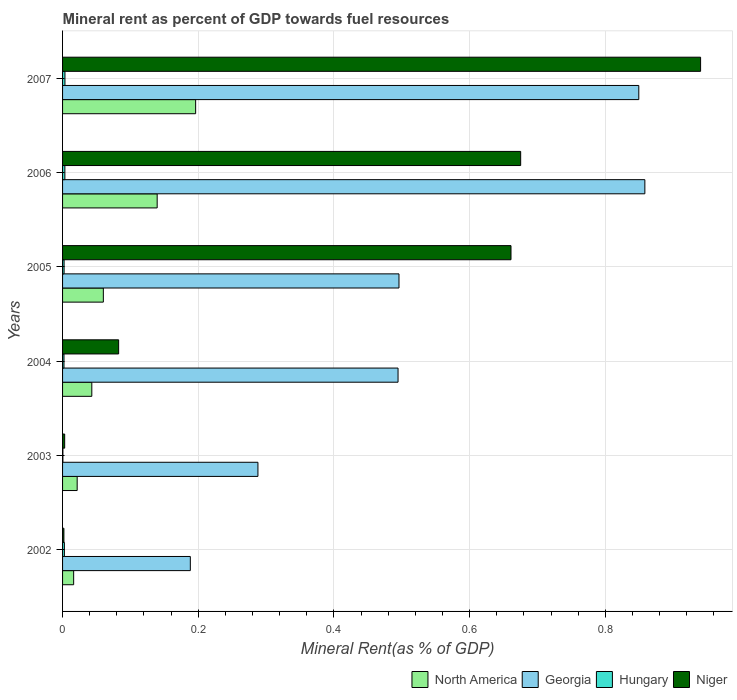How many groups of bars are there?
Your answer should be very brief. 6. Are the number of bars on each tick of the Y-axis equal?
Offer a very short reply. Yes. How many bars are there on the 5th tick from the top?
Give a very brief answer. 4. How many bars are there on the 5th tick from the bottom?
Keep it short and to the point. 4. What is the mineral rent in Georgia in 2003?
Provide a short and direct response. 0.29. Across all years, what is the maximum mineral rent in North America?
Make the answer very short. 0.2. Across all years, what is the minimum mineral rent in North America?
Offer a very short reply. 0.02. In which year was the mineral rent in Hungary maximum?
Make the answer very short. 2007. In which year was the mineral rent in Hungary minimum?
Ensure brevity in your answer.  2003. What is the total mineral rent in Hungary in the graph?
Your response must be concise. 0.01. What is the difference between the mineral rent in Georgia in 2004 and that in 2006?
Provide a short and direct response. -0.36. What is the difference between the mineral rent in North America in 2007 and the mineral rent in Niger in 2003?
Offer a very short reply. 0.19. What is the average mineral rent in Niger per year?
Make the answer very short. 0.39. In the year 2005, what is the difference between the mineral rent in Hungary and mineral rent in North America?
Ensure brevity in your answer.  -0.06. What is the ratio of the mineral rent in North America in 2003 to that in 2004?
Provide a succinct answer. 0.5. What is the difference between the highest and the second highest mineral rent in Hungary?
Ensure brevity in your answer.  0. What is the difference between the highest and the lowest mineral rent in North America?
Your answer should be very brief. 0.18. Is the sum of the mineral rent in North America in 2003 and 2006 greater than the maximum mineral rent in Niger across all years?
Give a very brief answer. No. Is it the case that in every year, the sum of the mineral rent in Hungary and mineral rent in Georgia is greater than the sum of mineral rent in Niger and mineral rent in North America?
Give a very brief answer. Yes. What does the 2nd bar from the top in 2005 represents?
Provide a succinct answer. Hungary. What does the 2nd bar from the bottom in 2002 represents?
Provide a succinct answer. Georgia. How many years are there in the graph?
Your answer should be compact. 6. Are the values on the major ticks of X-axis written in scientific E-notation?
Your answer should be very brief. No. Does the graph contain any zero values?
Provide a short and direct response. No. Does the graph contain grids?
Keep it short and to the point. Yes. Where does the legend appear in the graph?
Your answer should be very brief. Bottom right. How many legend labels are there?
Your response must be concise. 4. How are the legend labels stacked?
Your answer should be very brief. Horizontal. What is the title of the graph?
Your response must be concise. Mineral rent as percent of GDP towards fuel resources. What is the label or title of the X-axis?
Make the answer very short. Mineral Rent(as % of GDP). What is the label or title of the Y-axis?
Your response must be concise. Years. What is the Mineral Rent(as % of GDP) in North America in 2002?
Provide a succinct answer. 0.02. What is the Mineral Rent(as % of GDP) in Georgia in 2002?
Provide a succinct answer. 0.19. What is the Mineral Rent(as % of GDP) of Hungary in 2002?
Make the answer very short. 0. What is the Mineral Rent(as % of GDP) in Niger in 2002?
Your answer should be compact. 0. What is the Mineral Rent(as % of GDP) in North America in 2003?
Provide a short and direct response. 0.02. What is the Mineral Rent(as % of GDP) of Georgia in 2003?
Your answer should be very brief. 0.29. What is the Mineral Rent(as % of GDP) in Hungary in 2003?
Provide a succinct answer. 0. What is the Mineral Rent(as % of GDP) of Niger in 2003?
Ensure brevity in your answer.  0. What is the Mineral Rent(as % of GDP) in North America in 2004?
Make the answer very short. 0.04. What is the Mineral Rent(as % of GDP) in Georgia in 2004?
Provide a succinct answer. 0.49. What is the Mineral Rent(as % of GDP) of Hungary in 2004?
Give a very brief answer. 0. What is the Mineral Rent(as % of GDP) in Niger in 2004?
Provide a succinct answer. 0.08. What is the Mineral Rent(as % of GDP) in North America in 2005?
Your answer should be very brief. 0.06. What is the Mineral Rent(as % of GDP) of Georgia in 2005?
Make the answer very short. 0.5. What is the Mineral Rent(as % of GDP) in Hungary in 2005?
Make the answer very short. 0. What is the Mineral Rent(as % of GDP) in Niger in 2005?
Keep it short and to the point. 0.66. What is the Mineral Rent(as % of GDP) in North America in 2006?
Keep it short and to the point. 0.14. What is the Mineral Rent(as % of GDP) in Georgia in 2006?
Offer a terse response. 0.86. What is the Mineral Rent(as % of GDP) in Hungary in 2006?
Your response must be concise. 0. What is the Mineral Rent(as % of GDP) of Niger in 2006?
Offer a very short reply. 0.68. What is the Mineral Rent(as % of GDP) in North America in 2007?
Give a very brief answer. 0.2. What is the Mineral Rent(as % of GDP) in Georgia in 2007?
Give a very brief answer. 0.85. What is the Mineral Rent(as % of GDP) in Hungary in 2007?
Make the answer very short. 0. What is the Mineral Rent(as % of GDP) in Niger in 2007?
Your answer should be very brief. 0.94. Across all years, what is the maximum Mineral Rent(as % of GDP) of North America?
Your answer should be very brief. 0.2. Across all years, what is the maximum Mineral Rent(as % of GDP) in Georgia?
Offer a very short reply. 0.86. Across all years, what is the maximum Mineral Rent(as % of GDP) of Hungary?
Keep it short and to the point. 0. Across all years, what is the maximum Mineral Rent(as % of GDP) of Niger?
Offer a terse response. 0.94. Across all years, what is the minimum Mineral Rent(as % of GDP) in North America?
Provide a succinct answer. 0.02. Across all years, what is the minimum Mineral Rent(as % of GDP) of Georgia?
Keep it short and to the point. 0.19. Across all years, what is the minimum Mineral Rent(as % of GDP) in Hungary?
Your answer should be very brief. 0. Across all years, what is the minimum Mineral Rent(as % of GDP) of Niger?
Ensure brevity in your answer.  0. What is the total Mineral Rent(as % of GDP) of North America in the graph?
Ensure brevity in your answer.  0.48. What is the total Mineral Rent(as % of GDP) of Georgia in the graph?
Your answer should be compact. 3.17. What is the total Mineral Rent(as % of GDP) in Hungary in the graph?
Give a very brief answer. 0.01. What is the total Mineral Rent(as % of GDP) of Niger in the graph?
Offer a very short reply. 2.36. What is the difference between the Mineral Rent(as % of GDP) in North America in 2002 and that in 2003?
Give a very brief answer. -0.01. What is the difference between the Mineral Rent(as % of GDP) of Georgia in 2002 and that in 2003?
Keep it short and to the point. -0.1. What is the difference between the Mineral Rent(as % of GDP) of Hungary in 2002 and that in 2003?
Offer a very short reply. 0. What is the difference between the Mineral Rent(as % of GDP) of Niger in 2002 and that in 2003?
Make the answer very short. -0. What is the difference between the Mineral Rent(as % of GDP) in North America in 2002 and that in 2004?
Provide a short and direct response. -0.03. What is the difference between the Mineral Rent(as % of GDP) in Georgia in 2002 and that in 2004?
Your answer should be compact. -0.31. What is the difference between the Mineral Rent(as % of GDP) in Hungary in 2002 and that in 2004?
Offer a terse response. 0. What is the difference between the Mineral Rent(as % of GDP) in Niger in 2002 and that in 2004?
Give a very brief answer. -0.08. What is the difference between the Mineral Rent(as % of GDP) of North America in 2002 and that in 2005?
Offer a terse response. -0.04. What is the difference between the Mineral Rent(as % of GDP) in Georgia in 2002 and that in 2005?
Offer a very short reply. -0.31. What is the difference between the Mineral Rent(as % of GDP) in Hungary in 2002 and that in 2005?
Offer a terse response. 0. What is the difference between the Mineral Rent(as % of GDP) in Niger in 2002 and that in 2005?
Your response must be concise. -0.66. What is the difference between the Mineral Rent(as % of GDP) of North America in 2002 and that in 2006?
Keep it short and to the point. -0.12. What is the difference between the Mineral Rent(as % of GDP) in Georgia in 2002 and that in 2006?
Provide a succinct answer. -0.67. What is the difference between the Mineral Rent(as % of GDP) in Hungary in 2002 and that in 2006?
Give a very brief answer. -0. What is the difference between the Mineral Rent(as % of GDP) of Niger in 2002 and that in 2006?
Offer a terse response. -0.67. What is the difference between the Mineral Rent(as % of GDP) of North America in 2002 and that in 2007?
Give a very brief answer. -0.18. What is the difference between the Mineral Rent(as % of GDP) of Georgia in 2002 and that in 2007?
Ensure brevity in your answer.  -0.66. What is the difference between the Mineral Rent(as % of GDP) in Hungary in 2002 and that in 2007?
Your answer should be very brief. -0. What is the difference between the Mineral Rent(as % of GDP) of Niger in 2002 and that in 2007?
Offer a terse response. -0.94. What is the difference between the Mineral Rent(as % of GDP) of North America in 2003 and that in 2004?
Your answer should be very brief. -0.02. What is the difference between the Mineral Rent(as % of GDP) in Georgia in 2003 and that in 2004?
Your response must be concise. -0.21. What is the difference between the Mineral Rent(as % of GDP) of Hungary in 2003 and that in 2004?
Offer a very short reply. -0. What is the difference between the Mineral Rent(as % of GDP) of Niger in 2003 and that in 2004?
Provide a succinct answer. -0.08. What is the difference between the Mineral Rent(as % of GDP) of North America in 2003 and that in 2005?
Provide a succinct answer. -0.04. What is the difference between the Mineral Rent(as % of GDP) in Georgia in 2003 and that in 2005?
Provide a succinct answer. -0.21. What is the difference between the Mineral Rent(as % of GDP) of Hungary in 2003 and that in 2005?
Your response must be concise. -0. What is the difference between the Mineral Rent(as % of GDP) of Niger in 2003 and that in 2005?
Your answer should be compact. -0.66. What is the difference between the Mineral Rent(as % of GDP) of North America in 2003 and that in 2006?
Your response must be concise. -0.12. What is the difference between the Mineral Rent(as % of GDP) in Georgia in 2003 and that in 2006?
Offer a terse response. -0.57. What is the difference between the Mineral Rent(as % of GDP) of Hungary in 2003 and that in 2006?
Your answer should be very brief. -0. What is the difference between the Mineral Rent(as % of GDP) of Niger in 2003 and that in 2006?
Keep it short and to the point. -0.67. What is the difference between the Mineral Rent(as % of GDP) of North America in 2003 and that in 2007?
Offer a very short reply. -0.17. What is the difference between the Mineral Rent(as % of GDP) in Georgia in 2003 and that in 2007?
Offer a very short reply. -0.56. What is the difference between the Mineral Rent(as % of GDP) of Hungary in 2003 and that in 2007?
Your response must be concise. -0. What is the difference between the Mineral Rent(as % of GDP) in Niger in 2003 and that in 2007?
Ensure brevity in your answer.  -0.94. What is the difference between the Mineral Rent(as % of GDP) in North America in 2004 and that in 2005?
Provide a succinct answer. -0.02. What is the difference between the Mineral Rent(as % of GDP) in Georgia in 2004 and that in 2005?
Keep it short and to the point. -0. What is the difference between the Mineral Rent(as % of GDP) of Hungary in 2004 and that in 2005?
Provide a succinct answer. -0. What is the difference between the Mineral Rent(as % of GDP) in Niger in 2004 and that in 2005?
Offer a very short reply. -0.58. What is the difference between the Mineral Rent(as % of GDP) in North America in 2004 and that in 2006?
Offer a terse response. -0.1. What is the difference between the Mineral Rent(as % of GDP) in Georgia in 2004 and that in 2006?
Offer a terse response. -0.36. What is the difference between the Mineral Rent(as % of GDP) in Hungary in 2004 and that in 2006?
Provide a short and direct response. -0. What is the difference between the Mineral Rent(as % of GDP) in Niger in 2004 and that in 2006?
Provide a succinct answer. -0.59. What is the difference between the Mineral Rent(as % of GDP) of North America in 2004 and that in 2007?
Provide a short and direct response. -0.15. What is the difference between the Mineral Rent(as % of GDP) in Georgia in 2004 and that in 2007?
Provide a short and direct response. -0.35. What is the difference between the Mineral Rent(as % of GDP) in Hungary in 2004 and that in 2007?
Offer a terse response. -0. What is the difference between the Mineral Rent(as % of GDP) of Niger in 2004 and that in 2007?
Provide a short and direct response. -0.86. What is the difference between the Mineral Rent(as % of GDP) in North America in 2005 and that in 2006?
Make the answer very short. -0.08. What is the difference between the Mineral Rent(as % of GDP) in Georgia in 2005 and that in 2006?
Offer a terse response. -0.36. What is the difference between the Mineral Rent(as % of GDP) in Hungary in 2005 and that in 2006?
Your answer should be very brief. -0. What is the difference between the Mineral Rent(as % of GDP) of Niger in 2005 and that in 2006?
Offer a terse response. -0.01. What is the difference between the Mineral Rent(as % of GDP) of North America in 2005 and that in 2007?
Your answer should be very brief. -0.14. What is the difference between the Mineral Rent(as % of GDP) in Georgia in 2005 and that in 2007?
Your answer should be compact. -0.35. What is the difference between the Mineral Rent(as % of GDP) in Hungary in 2005 and that in 2007?
Provide a succinct answer. -0. What is the difference between the Mineral Rent(as % of GDP) of Niger in 2005 and that in 2007?
Make the answer very short. -0.28. What is the difference between the Mineral Rent(as % of GDP) in North America in 2006 and that in 2007?
Ensure brevity in your answer.  -0.06. What is the difference between the Mineral Rent(as % of GDP) in Georgia in 2006 and that in 2007?
Ensure brevity in your answer.  0.01. What is the difference between the Mineral Rent(as % of GDP) of Hungary in 2006 and that in 2007?
Provide a short and direct response. -0. What is the difference between the Mineral Rent(as % of GDP) of Niger in 2006 and that in 2007?
Your response must be concise. -0.27. What is the difference between the Mineral Rent(as % of GDP) of North America in 2002 and the Mineral Rent(as % of GDP) of Georgia in 2003?
Your response must be concise. -0.27. What is the difference between the Mineral Rent(as % of GDP) in North America in 2002 and the Mineral Rent(as % of GDP) in Hungary in 2003?
Your response must be concise. 0.02. What is the difference between the Mineral Rent(as % of GDP) of North America in 2002 and the Mineral Rent(as % of GDP) of Niger in 2003?
Your response must be concise. 0.01. What is the difference between the Mineral Rent(as % of GDP) in Georgia in 2002 and the Mineral Rent(as % of GDP) in Hungary in 2003?
Your answer should be compact. 0.19. What is the difference between the Mineral Rent(as % of GDP) of Georgia in 2002 and the Mineral Rent(as % of GDP) of Niger in 2003?
Keep it short and to the point. 0.19. What is the difference between the Mineral Rent(as % of GDP) of Hungary in 2002 and the Mineral Rent(as % of GDP) of Niger in 2003?
Offer a very short reply. -0. What is the difference between the Mineral Rent(as % of GDP) in North America in 2002 and the Mineral Rent(as % of GDP) in Georgia in 2004?
Your response must be concise. -0.48. What is the difference between the Mineral Rent(as % of GDP) in North America in 2002 and the Mineral Rent(as % of GDP) in Hungary in 2004?
Give a very brief answer. 0.01. What is the difference between the Mineral Rent(as % of GDP) in North America in 2002 and the Mineral Rent(as % of GDP) in Niger in 2004?
Your response must be concise. -0.07. What is the difference between the Mineral Rent(as % of GDP) in Georgia in 2002 and the Mineral Rent(as % of GDP) in Hungary in 2004?
Your answer should be very brief. 0.19. What is the difference between the Mineral Rent(as % of GDP) in Georgia in 2002 and the Mineral Rent(as % of GDP) in Niger in 2004?
Your answer should be compact. 0.11. What is the difference between the Mineral Rent(as % of GDP) of Hungary in 2002 and the Mineral Rent(as % of GDP) of Niger in 2004?
Keep it short and to the point. -0.08. What is the difference between the Mineral Rent(as % of GDP) of North America in 2002 and the Mineral Rent(as % of GDP) of Georgia in 2005?
Provide a short and direct response. -0.48. What is the difference between the Mineral Rent(as % of GDP) in North America in 2002 and the Mineral Rent(as % of GDP) in Hungary in 2005?
Ensure brevity in your answer.  0.01. What is the difference between the Mineral Rent(as % of GDP) of North America in 2002 and the Mineral Rent(as % of GDP) of Niger in 2005?
Provide a succinct answer. -0.64. What is the difference between the Mineral Rent(as % of GDP) in Georgia in 2002 and the Mineral Rent(as % of GDP) in Hungary in 2005?
Your response must be concise. 0.19. What is the difference between the Mineral Rent(as % of GDP) of Georgia in 2002 and the Mineral Rent(as % of GDP) of Niger in 2005?
Give a very brief answer. -0.47. What is the difference between the Mineral Rent(as % of GDP) of Hungary in 2002 and the Mineral Rent(as % of GDP) of Niger in 2005?
Offer a very short reply. -0.66. What is the difference between the Mineral Rent(as % of GDP) of North America in 2002 and the Mineral Rent(as % of GDP) of Georgia in 2006?
Offer a very short reply. -0.84. What is the difference between the Mineral Rent(as % of GDP) of North America in 2002 and the Mineral Rent(as % of GDP) of Hungary in 2006?
Your response must be concise. 0.01. What is the difference between the Mineral Rent(as % of GDP) of North America in 2002 and the Mineral Rent(as % of GDP) of Niger in 2006?
Ensure brevity in your answer.  -0.66. What is the difference between the Mineral Rent(as % of GDP) of Georgia in 2002 and the Mineral Rent(as % of GDP) of Hungary in 2006?
Make the answer very short. 0.18. What is the difference between the Mineral Rent(as % of GDP) of Georgia in 2002 and the Mineral Rent(as % of GDP) of Niger in 2006?
Give a very brief answer. -0.49. What is the difference between the Mineral Rent(as % of GDP) in Hungary in 2002 and the Mineral Rent(as % of GDP) in Niger in 2006?
Provide a succinct answer. -0.67. What is the difference between the Mineral Rent(as % of GDP) of North America in 2002 and the Mineral Rent(as % of GDP) of Georgia in 2007?
Provide a succinct answer. -0.83. What is the difference between the Mineral Rent(as % of GDP) in North America in 2002 and the Mineral Rent(as % of GDP) in Hungary in 2007?
Give a very brief answer. 0.01. What is the difference between the Mineral Rent(as % of GDP) of North America in 2002 and the Mineral Rent(as % of GDP) of Niger in 2007?
Make the answer very short. -0.92. What is the difference between the Mineral Rent(as % of GDP) of Georgia in 2002 and the Mineral Rent(as % of GDP) of Hungary in 2007?
Offer a terse response. 0.18. What is the difference between the Mineral Rent(as % of GDP) in Georgia in 2002 and the Mineral Rent(as % of GDP) in Niger in 2007?
Ensure brevity in your answer.  -0.75. What is the difference between the Mineral Rent(as % of GDP) of Hungary in 2002 and the Mineral Rent(as % of GDP) of Niger in 2007?
Offer a very short reply. -0.94. What is the difference between the Mineral Rent(as % of GDP) in North America in 2003 and the Mineral Rent(as % of GDP) in Georgia in 2004?
Ensure brevity in your answer.  -0.47. What is the difference between the Mineral Rent(as % of GDP) in North America in 2003 and the Mineral Rent(as % of GDP) in Hungary in 2004?
Make the answer very short. 0.02. What is the difference between the Mineral Rent(as % of GDP) of North America in 2003 and the Mineral Rent(as % of GDP) of Niger in 2004?
Provide a short and direct response. -0.06. What is the difference between the Mineral Rent(as % of GDP) in Georgia in 2003 and the Mineral Rent(as % of GDP) in Hungary in 2004?
Offer a terse response. 0.29. What is the difference between the Mineral Rent(as % of GDP) in Georgia in 2003 and the Mineral Rent(as % of GDP) in Niger in 2004?
Your answer should be compact. 0.21. What is the difference between the Mineral Rent(as % of GDP) of Hungary in 2003 and the Mineral Rent(as % of GDP) of Niger in 2004?
Offer a very short reply. -0.08. What is the difference between the Mineral Rent(as % of GDP) in North America in 2003 and the Mineral Rent(as % of GDP) in Georgia in 2005?
Keep it short and to the point. -0.47. What is the difference between the Mineral Rent(as % of GDP) in North America in 2003 and the Mineral Rent(as % of GDP) in Hungary in 2005?
Provide a short and direct response. 0.02. What is the difference between the Mineral Rent(as % of GDP) of North America in 2003 and the Mineral Rent(as % of GDP) of Niger in 2005?
Your response must be concise. -0.64. What is the difference between the Mineral Rent(as % of GDP) in Georgia in 2003 and the Mineral Rent(as % of GDP) in Hungary in 2005?
Provide a short and direct response. 0.29. What is the difference between the Mineral Rent(as % of GDP) in Georgia in 2003 and the Mineral Rent(as % of GDP) in Niger in 2005?
Your answer should be very brief. -0.37. What is the difference between the Mineral Rent(as % of GDP) of Hungary in 2003 and the Mineral Rent(as % of GDP) of Niger in 2005?
Make the answer very short. -0.66. What is the difference between the Mineral Rent(as % of GDP) in North America in 2003 and the Mineral Rent(as % of GDP) in Georgia in 2006?
Your answer should be compact. -0.84. What is the difference between the Mineral Rent(as % of GDP) of North America in 2003 and the Mineral Rent(as % of GDP) of Hungary in 2006?
Your answer should be very brief. 0.02. What is the difference between the Mineral Rent(as % of GDP) of North America in 2003 and the Mineral Rent(as % of GDP) of Niger in 2006?
Provide a short and direct response. -0.65. What is the difference between the Mineral Rent(as % of GDP) in Georgia in 2003 and the Mineral Rent(as % of GDP) in Hungary in 2006?
Give a very brief answer. 0.28. What is the difference between the Mineral Rent(as % of GDP) of Georgia in 2003 and the Mineral Rent(as % of GDP) of Niger in 2006?
Keep it short and to the point. -0.39. What is the difference between the Mineral Rent(as % of GDP) of Hungary in 2003 and the Mineral Rent(as % of GDP) of Niger in 2006?
Your answer should be very brief. -0.67. What is the difference between the Mineral Rent(as % of GDP) in North America in 2003 and the Mineral Rent(as % of GDP) in Georgia in 2007?
Your answer should be very brief. -0.83. What is the difference between the Mineral Rent(as % of GDP) in North America in 2003 and the Mineral Rent(as % of GDP) in Hungary in 2007?
Give a very brief answer. 0.02. What is the difference between the Mineral Rent(as % of GDP) of North America in 2003 and the Mineral Rent(as % of GDP) of Niger in 2007?
Ensure brevity in your answer.  -0.92. What is the difference between the Mineral Rent(as % of GDP) in Georgia in 2003 and the Mineral Rent(as % of GDP) in Hungary in 2007?
Ensure brevity in your answer.  0.28. What is the difference between the Mineral Rent(as % of GDP) of Georgia in 2003 and the Mineral Rent(as % of GDP) of Niger in 2007?
Your answer should be compact. -0.65. What is the difference between the Mineral Rent(as % of GDP) in Hungary in 2003 and the Mineral Rent(as % of GDP) in Niger in 2007?
Make the answer very short. -0.94. What is the difference between the Mineral Rent(as % of GDP) in North America in 2004 and the Mineral Rent(as % of GDP) in Georgia in 2005?
Your answer should be very brief. -0.45. What is the difference between the Mineral Rent(as % of GDP) in North America in 2004 and the Mineral Rent(as % of GDP) in Hungary in 2005?
Your answer should be very brief. 0.04. What is the difference between the Mineral Rent(as % of GDP) in North America in 2004 and the Mineral Rent(as % of GDP) in Niger in 2005?
Offer a terse response. -0.62. What is the difference between the Mineral Rent(as % of GDP) in Georgia in 2004 and the Mineral Rent(as % of GDP) in Hungary in 2005?
Offer a very short reply. 0.49. What is the difference between the Mineral Rent(as % of GDP) in Georgia in 2004 and the Mineral Rent(as % of GDP) in Niger in 2005?
Make the answer very short. -0.17. What is the difference between the Mineral Rent(as % of GDP) in Hungary in 2004 and the Mineral Rent(as % of GDP) in Niger in 2005?
Keep it short and to the point. -0.66. What is the difference between the Mineral Rent(as % of GDP) in North America in 2004 and the Mineral Rent(as % of GDP) in Georgia in 2006?
Your response must be concise. -0.82. What is the difference between the Mineral Rent(as % of GDP) of North America in 2004 and the Mineral Rent(as % of GDP) of Hungary in 2006?
Keep it short and to the point. 0.04. What is the difference between the Mineral Rent(as % of GDP) of North America in 2004 and the Mineral Rent(as % of GDP) of Niger in 2006?
Provide a short and direct response. -0.63. What is the difference between the Mineral Rent(as % of GDP) in Georgia in 2004 and the Mineral Rent(as % of GDP) in Hungary in 2006?
Make the answer very short. 0.49. What is the difference between the Mineral Rent(as % of GDP) of Georgia in 2004 and the Mineral Rent(as % of GDP) of Niger in 2006?
Make the answer very short. -0.18. What is the difference between the Mineral Rent(as % of GDP) in Hungary in 2004 and the Mineral Rent(as % of GDP) in Niger in 2006?
Make the answer very short. -0.67. What is the difference between the Mineral Rent(as % of GDP) in North America in 2004 and the Mineral Rent(as % of GDP) in Georgia in 2007?
Your response must be concise. -0.81. What is the difference between the Mineral Rent(as % of GDP) in North America in 2004 and the Mineral Rent(as % of GDP) in Hungary in 2007?
Offer a terse response. 0.04. What is the difference between the Mineral Rent(as % of GDP) of North America in 2004 and the Mineral Rent(as % of GDP) of Niger in 2007?
Make the answer very short. -0.9. What is the difference between the Mineral Rent(as % of GDP) in Georgia in 2004 and the Mineral Rent(as % of GDP) in Hungary in 2007?
Give a very brief answer. 0.49. What is the difference between the Mineral Rent(as % of GDP) of Georgia in 2004 and the Mineral Rent(as % of GDP) of Niger in 2007?
Your answer should be very brief. -0.45. What is the difference between the Mineral Rent(as % of GDP) in Hungary in 2004 and the Mineral Rent(as % of GDP) in Niger in 2007?
Your response must be concise. -0.94. What is the difference between the Mineral Rent(as % of GDP) in North America in 2005 and the Mineral Rent(as % of GDP) in Georgia in 2006?
Offer a very short reply. -0.8. What is the difference between the Mineral Rent(as % of GDP) in North America in 2005 and the Mineral Rent(as % of GDP) in Hungary in 2006?
Provide a short and direct response. 0.06. What is the difference between the Mineral Rent(as % of GDP) of North America in 2005 and the Mineral Rent(as % of GDP) of Niger in 2006?
Your response must be concise. -0.62. What is the difference between the Mineral Rent(as % of GDP) in Georgia in 2005 and the Mineral Rent(as % of GDP) in Hungary in 2006?
Give a very brief answer. 0.49. What is the difference between the Mineral Rent(as % of GDP) of Georgia in 2005 and the Mineral Rent(as % of GDP) of Niger in 2006?
Your response must be concise. -0.18. What is the difference between the Mineral Rent(as % of GDP) of Hungary in 2005 and the Mineral Rent(as % of GDP) of Niger in 2006?
Your answer should be very brief. -0.67. What is the difference between the Mineral Rent(as % of GDP) in North America in 2005 and the Mineral Rent(as % of GDP) in Georgia in 2007?
Make the answer very short. -0.79. What is the difference between the Mineral Rent(as % of GDP) in North America in 2005 and the Mineral Rent(as % of GDP) in Hungary in 2007?
Offer a terse response. 0.06. What is the difference between the Mineral Rent(as % of GDP) in North America in 2005 and the Mineral Rent(as % of GDP) in Niger in 2007?
Ensure brevity in your answer.  -0.88. What is the difference between the Mineral Rent(as % of GDP) of Georgia in 2005 and the Mineral Rent(as % of GDP) of Hungary in 2007?
Make the answer very short. 0.49. What is the difference between the Mineral Rent(as % of GDP) in Georgia in 2005 and the Mineral Rent(as % of GDP) in Niger in 2007?
Ensure brevity in your answer.  -0.44. What is the difference between the Mineral Rent(as % of GDP) in Hungary in 2005 and the Mineral Rent(as % of GDP) in Niger in 2007?
Make the answer very short. -0.94. What is the difference between the Mineral Rent(as % of GDP) in North America in 2006 and the Mineral Rent(as % of GDP) in Georgia in 2007?
Offer a terse response. -0.71. What is the difference between the Mineral Rent(as % of GDP) in North America in 2006 and the Mineral Rent(as % of GDP) in Hungary in 2007?
Your answer should be compact. 0.14. What is the difference between the Mineral Rent(as % of GDP) of North America in 2006 and the Mineral Rent(as % of GDP) of Niger in 2007?
Keep it short and to the point. -0.8. What is the difference between the Mineral Rent(as % of GDP) in Georgia in 2006 and the Mineral Rent(as % of GDP) in Hungary in 2007?
Give a very brief answer. 0.85. What is the difference between the Mineral Rent(as % of GDP) in Georgia in 2006 and the Mineral Rent(as % of GDP) in Niger in 2007?
Provide a short and direct response. -0.08. What is the difference between the Mineral Rent(as % of GDP) in Hungary in 2006 and the Mineral Rent(as % of GDP) in Niger in 2007?
Your response must be concise. -0.94. What is the average Mineral Rent(as % of GDP) of North America per year?
Make the answer very short. 0.08. What is the average Mineral Rent(as % of GDP) in Georgia per year?
Your answer should be compact. 0.53. What is the average Mineral Rent(as % of GDP) in Hungary per year?
Make the answer very short. 0. What is the average Mineral Rent(as % of GDP) in Niger per year?
Your response must be concise. 0.39. In the year 2002, what is the difference between the Mineral Rent(as % of GDP) of North America and Mineral Rent(as % of GDP) of Georgia?
Make the answer very short. -0.17. In the year 2002, what is the difference between the Mineral Rent(as % of GDP) in North America and Mineral Rent(as % of GDP) in Hungary?
Provide a short and direct response. 0.01. In the year 2002, what is the difference between the Mineral Rent(as % of GDP) in North America and Mineral Rent(as % of GDP) in Niger?
Provide a succinct answer. 0.01. In the year 2002, what is the difference between the Mineral Rent(as % of GDP) of Georgia and Mineral Rent(as % of GDP) of Hungary?
Provide a succinct answer. 0.19. In the year 2002, what is the difference between the Mineral Rent(as % of GDP) in Georgia and Mineral Rent(as % of GDP) in Niger?
Provide a short and direct response. 0.19. In the year 2002, what is the difference between the Mineral Rent(as % of GDP) in Hungary and Mineral Rent(as % of GDP) in Niger?
Make the answer very short. 0. In the year 2003, what is the difference between the Mineral Rent(as % of GDP) of North America and Mineral Rent(as % of GDP) of Georgia?
Offer a very short reply. -0.27. In the year 2003, what is the difference between the Mineral Rent(as % of GDP) in North America and Mineral Rent(as % of GDP) in Hungary?
Give a very brief answer. 0.02. In the year 2003, what is the difference between the Mineral Rent(as % of GDP) in North America and Mineral Rent(as % of GDP) in Niger?
Your answer should be very brief. 0.02. In the year 2003, what is the difference between the Mineral Rent(as % of GDP) in Georgia and Mineral Rent(as % of GDP) in Hungary?
Give a very brief answer. 0.29. In the year 2003, what is the difference between the Mineral Rent(as % of GDP) of Georgia and Mineral Rent(as % of GDP) of Niger?
Your answer should be very brief. 0.28. In the year 2003, what is the difference between the Mineral Rent(as % of GDP) of Hungary and Mineral Rent(as % of GDP) of Niger?
Your answer should be compact. -0. In the year 2004, what is the difference between the Mineral Rent(as % of GDP) of North America and Mineral Rent(as % of GDP) of Georgia?
Give a very brief answer. -0.45. In the year 2004, what is the difference between the Mineral Rent(as % of GDP) in North America and Mineral Rent(as % of GDP) in Hungary?
Ensure brevity in your answer.  0.04. In the year 2004, what is the difference between the Mineral Rent(as % of GDP) of North America and Mineral Rent(as % of GDP) of Niger?
Keep it short and to the point. -0.04. In the year 2004, what is the difference between the Mineral Rent(as % of GDP) in Georgia and Mineral Rent(as % of GDP) in Hungary?
Your answer should be very brief. 0.49. In the year 2004, what is the difference between the Mineral Rent(as % of GDP) of Georgia and Mineral Rent(as % of GDP) of Niger?
Ensure brevity in your answer.  0.41. In the year 2004, what is the difference between the Mineral Rent(as % of GDP) in Hungary and Mineral Rent(as % of GDP) in Niger?
Make the answer very short. -0.08. In the year 2005, what is the difference between the Mineral Rent(as % of GDP) in North America and Mineral Rent(as % of GDP) in Georgia?
Provide a short and direct response. -0.44. In the year 2005, what is the difference between the Mineral Rent(as % of GDP) of North America and Mineral Rent(as % of GDP) of Hungary?
Give a very brief answer. 0.06. In the year 2005, what is the difference between the Mineral Rent(as % of GDP) of North America and Mineral Rent(as % of GDP) of Niger?
Offer a very short reply. -0.6. In the year 2005, what is the difference between the Mineral Rent(as % of GDP) of Georgia and Mineral Rent(as % of GDP) of Hungary?
Keep it short and to the point. 0.49. In the year 2005, what is the difference between the Mineral Rent(as % of GDP) of Georgia and Mineral Rent(as % of GDP) of Niger?
Your answer should be very brief. -0.17. In the year 2005, what is the difference between the Mineral Rent(as % of GDP) of Hungary and Mineral Rent(as % of GDP) of Niger?
Offer a very short reply. -0.66. In the year 2006, what is the difference between the Mineral Rent(as % of GDP) in North America and Mineral Rent(as % of GDP) in Georgia?
Provide a short and direct response. -0.72. In the year 2006, what is the difference between the Mineral Rent(as % of GDP) of North America and Mineral Rent(as % of GDP) of Hungary?
Keep it short and to the point. 0.14. In the year 2006, what is the difference between the Mineral Rent(as % of GDP) of North America and Mineral Rent(as % of GDP) of Niger?
Offer a very short reply. -0.54. In the year 2006, what is the difference between the Mineral Rent(as % of GDP) of Georgia and Mineral Rent(as % of GDP) of Hungary?
Provide a succinct answer. 0.85. In the year 2006, what is the difference between the Mineral Rent(as % of GDP) of Georgia and Mineral Rent(as % of GDP) of Niger?
Ensure brevity in your answer.  0.18. In the year 2006, what is the difference between the Mineral Rent(as % of GDP) of Hungary and Mineral Rent(as % of GDP) of Niger?
Ensure brevity in your answer.  -0.67. In the year 2007, what is the difference between the Mineral Rent(as % of GDP) in North America and Mineral Rent(as % of GDP) in Georgia?
Offer a very short reply. -0.65. In the year 2007, what is the difference between the Mineral Rent(as % of GDP) in North America and Mineral Rent(as % of GDP) in Hungary?
Ensure brevity in your answer.  0.19. In the year 2007, what is the difference between the Mineral Rent(as % of GDP) of North America and Mineral Rent(as % of GDP) of Niger?
Give a very brief answer. -0.74. In the year 2007, what is the difference between the Mineral Rent(as % of GDP) of Georgia and Mineral Rent(as % of GDP) of Hungary?
Provide a short and direct response. 0.85. In the year 2007, what is the difference between the Mineral Rent(as % of GDP) in Georgia and Mineral Rent(as % of GDP) in Niger?
Make the answer very short. -0.09. In the year 2007, what is the difference between the Mineral Rent(as % of GDP) of Hungary and Mineral Rent(as % of GDP) of Niger?
Provide a short and direct response. -0.94. What is the ratio of the Mineral Rent(as % of GDP) in North America in 2002 to that in 2003?
Provide a succinct answer. 0.76. What is the ratio of the Mineral Rent(as % of GDP) of Georgia in 2002 to that in 2003?
Offer a terse response. 0.65. What is the ratio of the Mineral Rent(as % of GDP) in Hungary in 2002 to that in 2003?
Offer a terse response. 5.7. What is the ratio of the Mineral Rent(as % of GDP) in Niger in 2002 to that in 2003?
Ensure brevity in your answer.  0.64. What is the ratio of the Mineral Rent(as % of GDP) of North America in 2002 to that in 2004?
Provide a succinct answer. 0.38. What is the ratio of the Mineral Rent(as % of GDP) of Georgia in 2002 to that in 2004?
Your answer should be very brief. 0.38. What is the ratio of the Mineral Rent(as % of GDP) of Hungary in 2002 to that in 2004?
Provide a succinct answer. 1.28. What is the ratio of the Mineral Rent(as % of GDP) in Niger in 2002 to that in 2004?
Provide a short and direct response. 0.02. What is the ratio of the Mineral Rent(as % of GDP) in North America in 2002 to that in 2005?
Offer a terse response. 0.27. What is the ratio of the Mineral Rent(as % of GDP) of Georgia in 2002 to that in 2005?
Make the answer very short. 0.38. What is the ratio of the Mineral Rent(as % of GDP) in Hungary in 2002 to that in 2005?
Offer a very short reply. 1.19. What is the ratio of the Mineral Rent(as % of GDP) in Niger in 2002 to that in 2005?
Your answer should be compact. 0. What is the ratio of the Mineral Rent(as % of GDP) in North America in 2002 to that in 2006?
Keep it short and to the point. 0.12. What is the ratio of the Mineral Rent(as % of GDP) in Georgia in 2002 to that in 2006?
Ensure brevity in your answer.  0.22. What is the ratio of the Mineral Rent(as % of GDP) of Hungary in 2002 to that in 2006?
Keep it short and to the point. 0.79. What is the ratio of the Mineral Rent(as % of GDP) in Niger in 2002 to that in 2006?
Offer a terse response. 0. What is the ratio of the Mineral Rent(as % of GDP) in North America in 2002 to that in 2007?
Keep it short and to the point. 0.08. What is the ratio of the Mineral Rent(as % of GDP) of Georgia in 2002 to that in 2007?
Your answer should be very brief. 0.22. What is the ratio of the Mineral Rent(as % of GDP) in Hungary in 2002 to that in 2007?
Your answer should be very brief. 0.76. What is the ratio of the Mineral Rent(as % of GDP) in Niger in 2002 to that in 2007?
Your answer should be very brief. 0. What is the ratio of the Mineral Rent(as % of GDP) in North America in 2003 to that in 2004?
Make the answer very short. 0.5. What is the ratio of the Mineral Rent(as % of GDP) in Georgia in 2003 to that in 2004?
Your response must be concise. 0.58. What is the ratio of the Mineral Rent(as % of GDP) of Hungary in 2003 to that in 2004?
Keep it short and to the point. 0.22. What is the ratio of the Mineral Rent(as % of GDP) in Niger in 2003 to that in 2004?
Your answer should be compact. 0.04. What is the ratio of the Mineral Rent(as % of GDP) in North America in 2003 to that in 2005?
Provide a short and direct response. 0.36. What is the ratio of the Mineral Rent(as % of GDP) in Georgia in 2003 to that in 2005?
Make the answer very short. 0.58. What is the ratio of the Mineral Rent(as % of GDP) in Hungary in 2003 to that in 2005?
Provide a succinct answer. 0.21. What is the ratio of the Mineral Rent(as % of GDP) of Niger in 2003 to that in 2005?
Make the answer very short. 0. What is the ratio of the Mineral Rent(as % of GDP) in North America in 2003 to that in 2006?
Provide a succinct answer. 0.15. What is the ratio of the Mineral Rent(as % of GDP) in Georgia in 2003 to that in 2006?
Provide a succinct answer. 0.34. What is the ratio of the Mineral Rent(as % of GDP) of Hungary in 2003 to that in 2006?
Keep it short and to the point. 0.14. What is the ratio of the Mineral Rent(as % of GDP) in Niger in 2003 to that in 2006?
Offer a very short reply. 0. What is the ratio of the Mineral Rent(as % of GDP) of North America in 2003 to that in 2007?
Provide a succinct answer. 0.11. What is the ratio of the Mineral Rent(as % of GDP) in Georgia in 2003 to that in 2007?
Your answer should be compact. 0.34. What is the ratio of the Mineral Rent(as % of GDP) in Hungary in 2003 to that in 2007?
Your answer should be very brief. 0.13. What is the ratio of the Mineral Rent(as % of GDP) of Niger in 2003 to that in 2007?
Keep it short and to the point. 0. What is the ratio of the Mineral Rent(as % of GDP) of North America in 2004 to that in 2005?
Offer a terse response. 0.72. What is the ratio of the Mineral Rent(as % of GDP) in Georgia in 2004 to that in 2005?
Offer a very short reply. 1. What is the ratio of the Mineral Rent(as % of GDP) of Hungary in 2004 to that in 2005?
Ensure brevity in your answer.  0.93. What is the ratio of the Mineral Rent(as % of GDP) of Niger in 2004 to that in 2005?
Provide a succinct answer. 0.12. What is the ratio of the Mineral Rent(as % of GDP) in North America in 2004 to that in 2006?
Offer a terse response. 0.31. What is the ratio of the Mineral Rent(as % of GDP) in Georgia in 2004 to that in 2006?
Your answer should be compact. 0.58. What is the ratio of the Mineral Rent(as % of GDP) in Hungary in 2004 to that in 2006?
Offer a very short reply. 0.62. What is the ratio of the Mineral Rent(as % of GDP) of Niger in 2004 to that in 2006?
Offer a very short reply. 0.12. What is the ratio of the Mineral Rent(as % of GDP) in North America in 2004 to that in 2007?
Offer a terse response. 0.22. What is the ratio of the Mineral Rent(as % of GDP) in Georgia in 2004 to that in 2007?
Offer a very short reply. 0.58. What is the ratio of the Mineral Rent(as % of GDP) of Hungary in 2004 to that in 2007?
Your answer should be very brief. 0.6. What is the ratio of the Mineral Rent(as % of GDP) of Niger in 2004 to that in 2007?
Give a very brief answer. 0.09. What is the ratio of the Mineral Rent(as % of GDP) in North America in 2005 to that in 2006?
Your answer should be compact. 0.43. What is the ratio of the Mineral Rent(as % of GDP) of Georgia in 2005 to that in 2006?
Offer a very short reply. 0.58. What is the ratio of the Mineral Rent(as % of GDP) of Hungary in 2005 to that in 2006?
Offer a terse response. 0.67. What is the ratio of the Mineral Rent(as % of GDP) in Niger in 2005 to that in 2006?
Provide a short and direct response. 0.98. What is the ratio of the Mineral Rent(as % of GDP) in North America in 2005 to that in 2007?
Your answer should be compact. 0.31. What is the ratio of the Mineral Rent(as % of GDP) in Georgia in 2005 to that in 2007?
Give a very brief answer. 0.58. What is the ratio of the Mineral Rent(as % of GDP) in Hungary in 2005 to that in 2007?
Keep it short and to the point. 0.64. What is the ratio of the Mineral Rent(as % of GDP) of Niger in 2005 to that in 2007?
Your answer should be compact. 0.7. What is the ratio of the Mineral Rent(as % of GDP) of North America in 2006 to that in 2007?
Keep it short and to the point. 0.71. What is the ratio of the Mineral Rent(as % of GDP) of Georgia in 2006 to that in 2007?
Give a very brief answer. 1.01. What is the ratio of the Mineral Rent(as % of GDP) of Hungary in 2006 to that in 2007?
Ensure brevity in your answer.  0.96. What is the ratio of the Mineral Rent(as % of GDP) in Niger in 2006 to that in 2007?
Your answer should be very brief. 0.72. What is the difference between the highest and the second highest Mineral Rent(as % of GDP) of North America?
Your answer should be very brief. 0.06. What is the difference between the highest and the second highest Mineral Rent(as % of GDP) of Georgia?
Your response must be concise. 0.01. What is the difference between the highest and the second highest Mineral Rent(as % of GDP) of Niger?
Make the answer very short. 0.27. What is the difference between the highest and the lowest Mineral Rent(as % of GDP) of North America?
Your answer should be very brief. 0.18. What is the difference between the highest and the lowest Mineral Rent(as % of GDP) of Georgia?
Provide a short and direct response. 0.67. What is the difference between the highest and the lowest Mineral Rent(as % of GDP) of Hungary?
Ensure brevity in your answer.  0. What is the difference between the highest and the lowest Mineral Rent(as % of GDP) in Niger?
Provide a short and direct response. 0.94. 